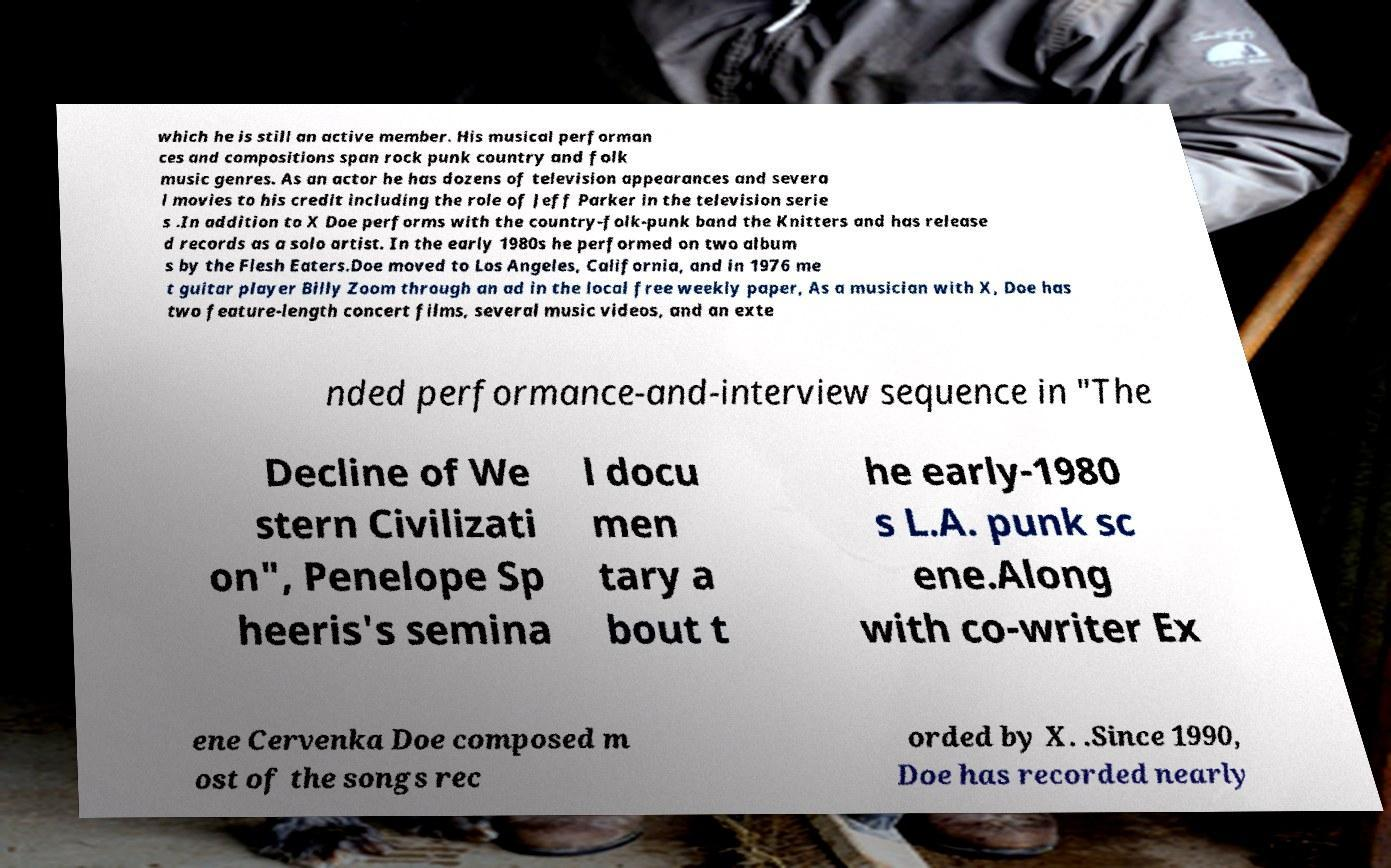There's text embedded in this image that I need extracted. Can you transcribe it verbatim? which he is still an active member. His musical performan ces and compositions span rock punk country and folk music genres. As an actor he has dozens of television appearances and severa l movies to his credit including the role of Jeff Parker in the television serie s .In addition to X Doe performs with the country-folk-punk band the Knitters and has release d records as a solo artist. In the early 1980s he performed on two album s by the Flesh Eaters.Doe moved to Los Angeles, California, and in 1976 me t guitar player Billy Zoom through an ad in the local free weekly paper, As a musician with X, Doe has two feature-length concert films, several music videos, and an exte nded performance-and-interview sequence in "The Decline of We stern Civilizati on", Penelope Sp heeris's semina l docu men tary a bout t he early-1980 s L.A. punk sc ene.Along with co-writer Ex ene Cervenka Doe composed m ost of the songs rec orded by X. .Since 1990, Doe has recorded nearly 